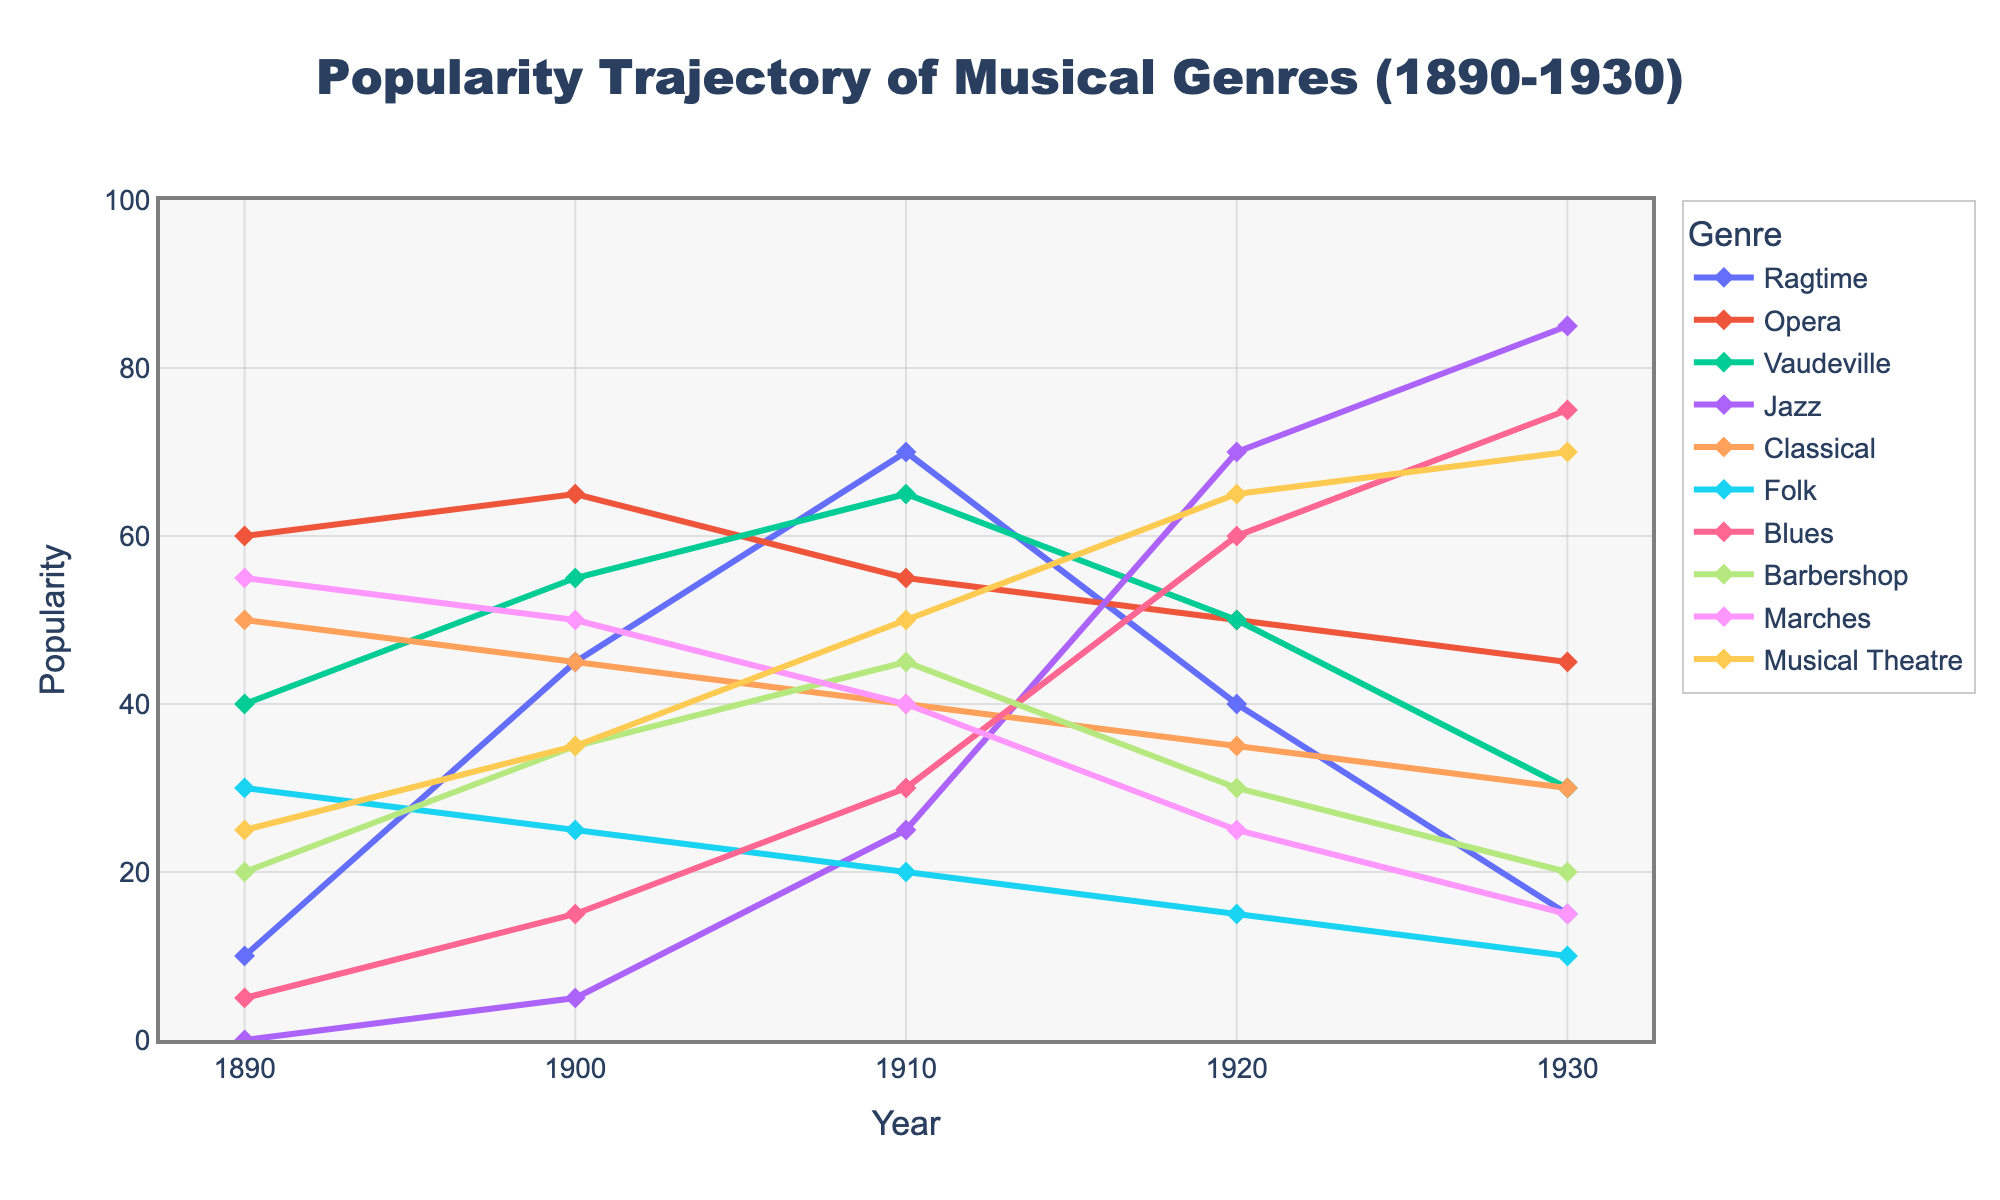What musical genre saw the most significant increase in popularity from 1900 to 1930? To determine the most significant increase in popularity, compare the popularity values of each genre in 1900 and 1930. Ragtime increased from 45 to 15 (-30), Opera from 65 to 45 (-20), Vaudeville from 55 to 30 (-25), Jazz from 5 to 85 (+80), Classical from 45 to 30 (-15), Folk from 25 to 10 (-15), Blues from 15 to 75 (+60), Barbershop from 35 to 20 (-15), Marches from 50 to 15 (-35), Musical Theatre from 35 to 70 (+35). Jazz saw the most significant increase in popularity.
Answer: Jazz Which two musical genres had the highest popularity in the year 1920? To find the two genres with the highest popularity in 1920, examine the popularity values for each genre that year: Ragtime (40), Opera (50), Vaudeville (50), Jazz (70), Classical (35), Folk (15), Blues (60), Barbershop (30), Marches (25), Musical Theatre (65). The two genres with the highest popularity are Jazz and Musical Theatre.
Answer: Jazz and Musical Theatre How did the popularity of the Blues genre change over the decades? Evaluate the changes in Blues from decade to decade: 1890 (5), 1900 (15), 1910 (30), 1920 (60), 1930 (75). The popularity of Blues consistently increased over each decade.
Answer: Increased consistently Which musical genre experienced the largest decline in popularity from 1910 to 1930? Calculate the difference in popularity for each genre between 1910 and 1930: Ragtime (70-15 = -55), Opera (55-45 = -10), Vaudeville (65-30 = -35), Jazz (25-85 = +60), Classical (40-30 = -10), Folk (20-10 = -10), Blues (30-75 = +45), Barbershop (45-20 = -25), Marches (40-15 = -25), Musical Theatre (50-70 = +20). Ragtime had the largest decline.
Answer: Ragtime What is the average popularity of the Classical genre across all years presented in the figure? Add the popularity values for Classical in each year and divide by the number of years: (50 + 45 + 40 + 35 + 30) / 5 = 200 / 5 = 40.
Answer: 40 Between which two consecutive decades did Ragtime experience the largest drop in popularity? Compare the drops between each consecutive decade for Ragtime: from 1890 to 1900 (+35), 1900 to 1910 (+25), 1910 to 1920 (-30), and 1920 to 1930 (-25). The largest drop occurred between 1910 and 1920.
Answer: 1910 and 1920 